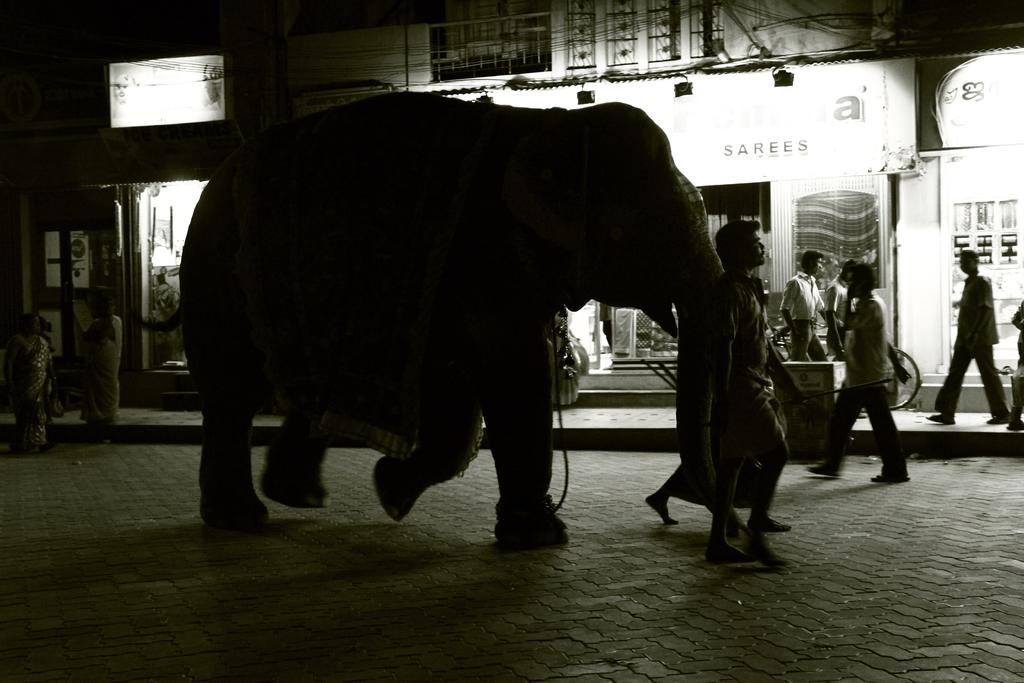Who or what can be seen in the image? There are persons and an elephant in the image. Can you describe the location of the elephant in the image? The elephant is in the middle of the image. What is visible in the background of the image? There is a wall in the background of the image. Can you tell me how many pans are being used by the persons in the image? There is no mention of pans in the image, so it is not possible to determine if any are being used. 